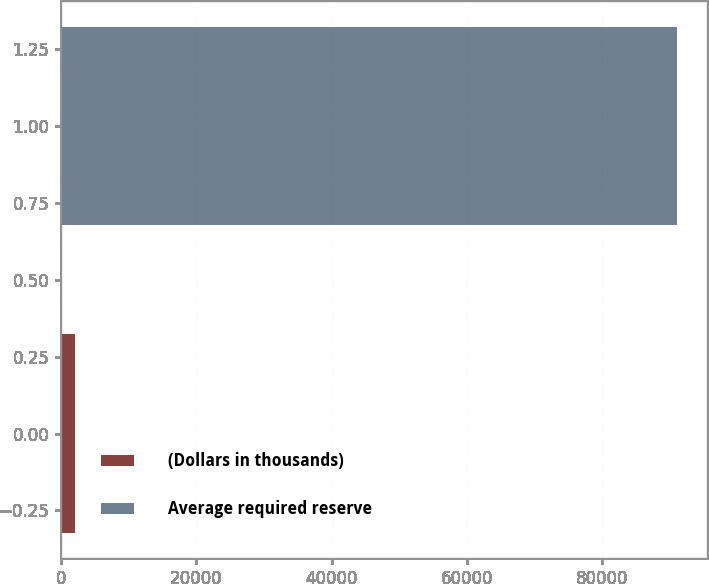<chart> <loc_0><loc_0><loc_500><loc_500><bar_chart><fcel>(Dollars in thousands)<fcel>Average required reserve<nl><fcel>2011<fcel>91046<nl></chart> 